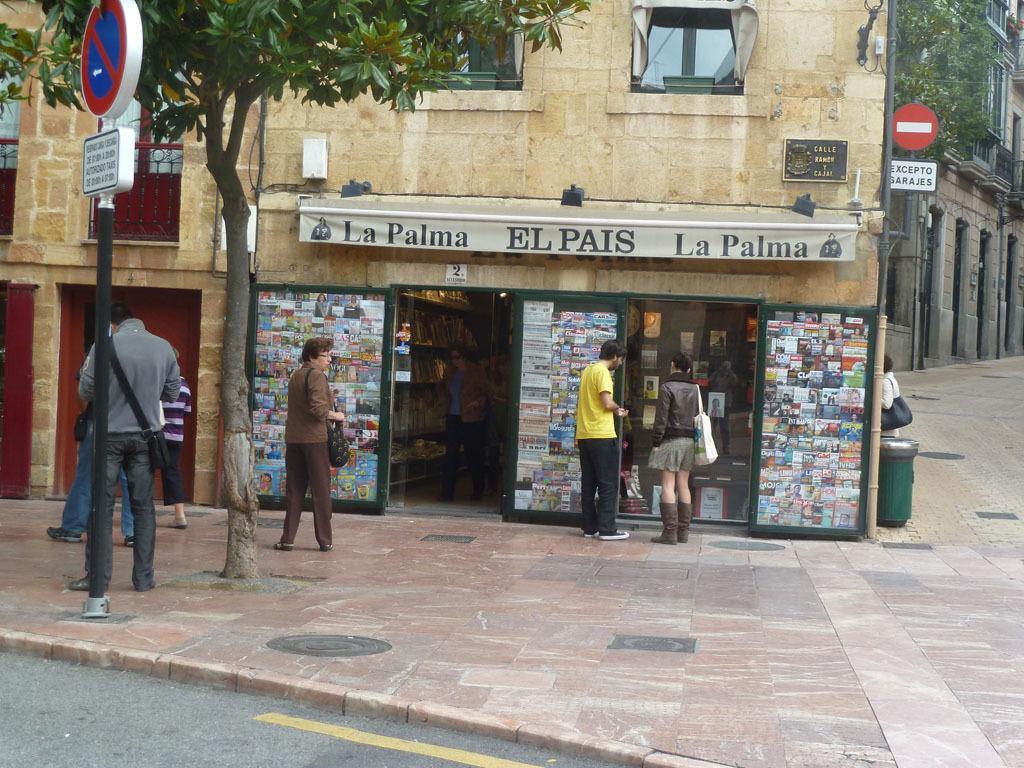How would you summarize this image in a sentence or two? In this image we can see a building, people, poles, boards, road, footpath, tree, books, and other objects. 